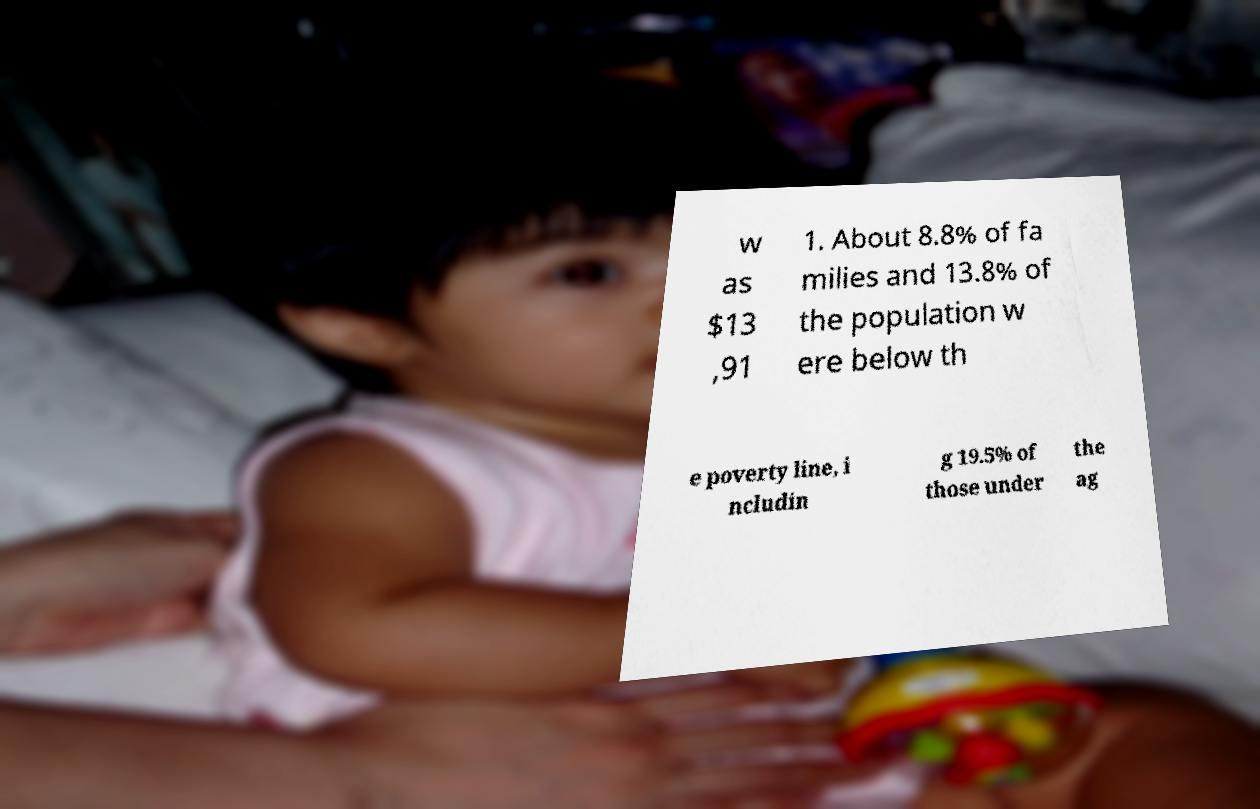I need the written content from this picture converted into text. Can you do that? w as $13 ,91 1. About 8.8% of fa milies and 13.8% of the population w ere below th e poverty line, i ncludin g 19.5% of those under the ag 